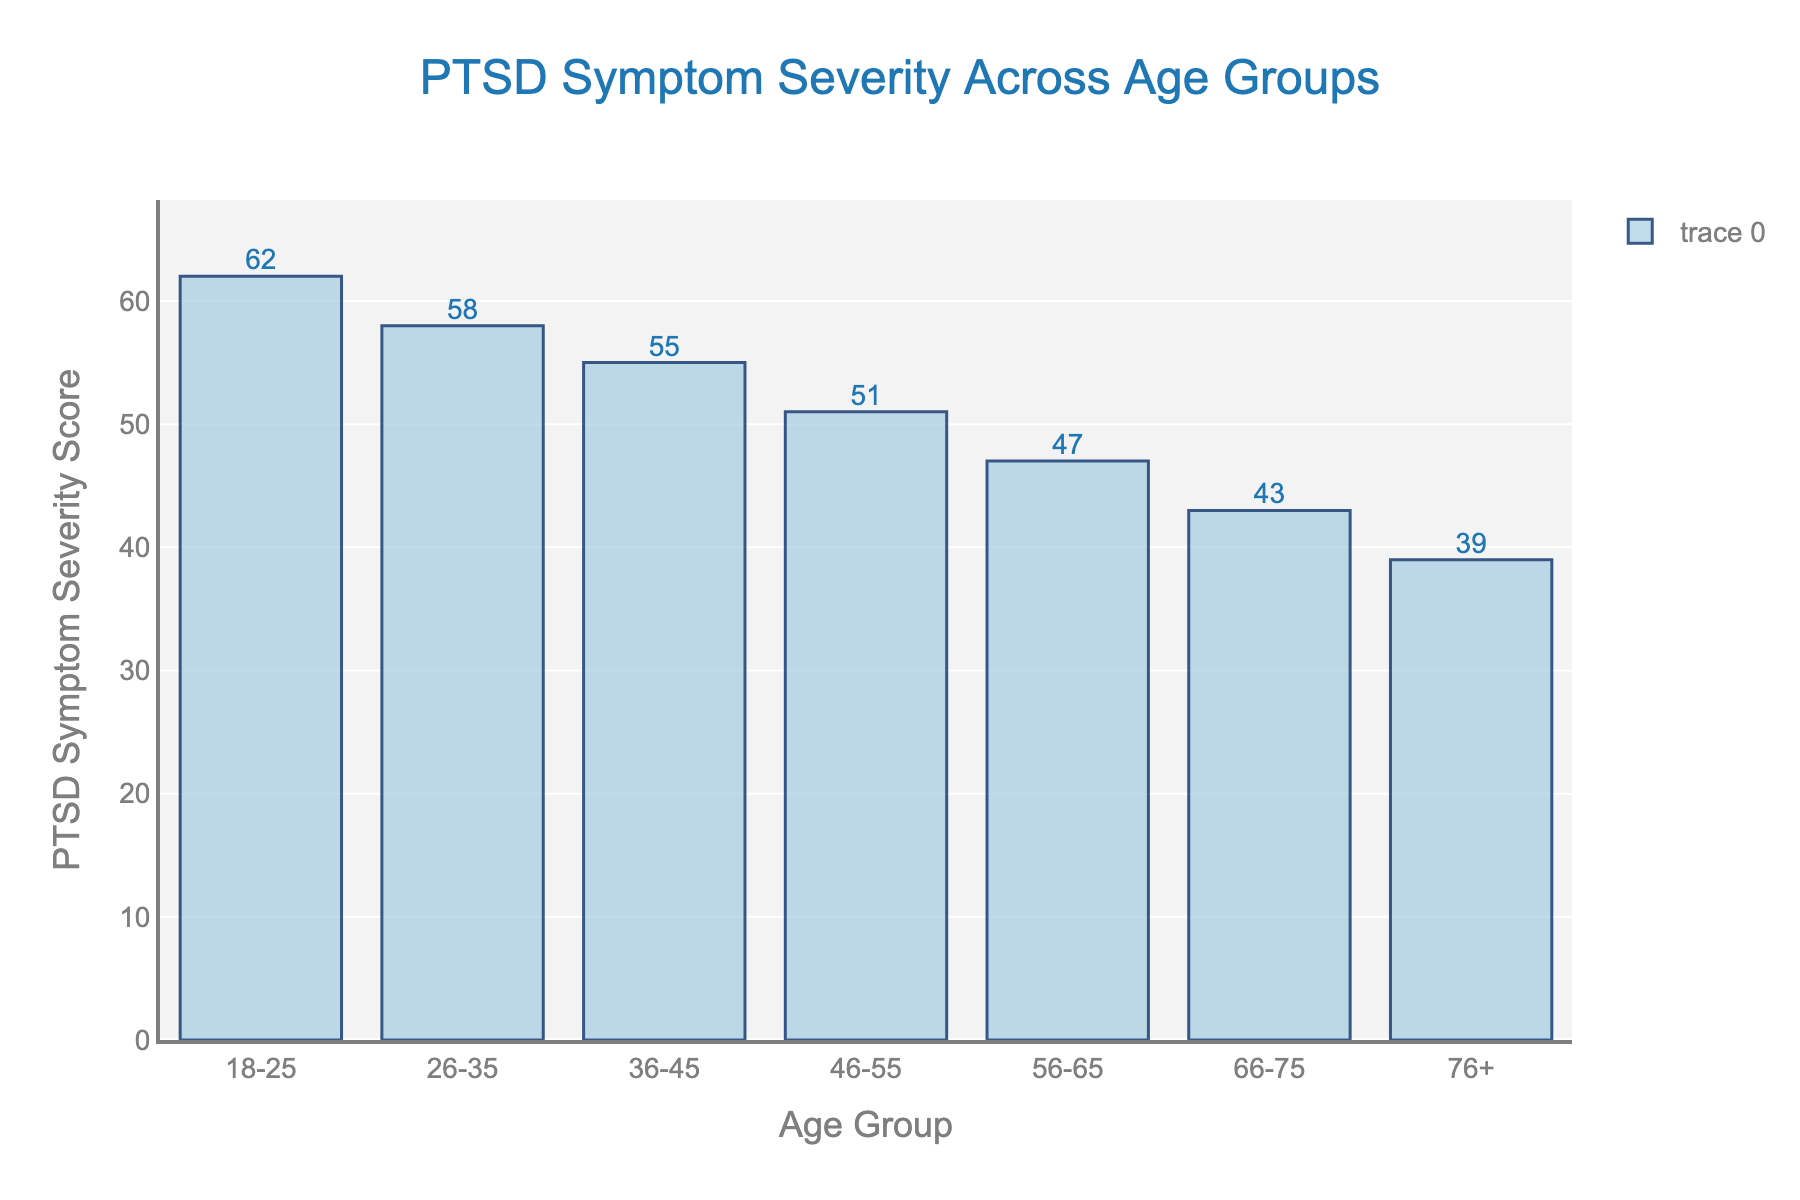What age group has the highest PTSD symptom severity score? The bar for the 18-25 age group is the tallest, indicating it has the highest score.
Answer: 18-25 Which age group has the lowest PTSD symptom severity score? The bar for the 76+ age group is the shortest, indicating it has the lowest score.
Answer: 76+ What is the difference in PTSD symptom severity score between the 26-35 and 56-65 age groups? The score for 26-35 is 58, and for 56-65 it is 47. Subtract 47 from 58 to get the difference.
Answer: 11 What is the average PTSD symptom severity score for the age groups 36-45 and 46-55? Add the scores for 36-45 (55) and 46-55 (51), then divide by 2 to get the average.
Answer: 53 How much lower is the PTSD symptom severity score in the 66-75 age group compared to the 18-25 age group? Subtract the score for 66-75 (43) from the score for 18-25 (62).
Answer: 19 Which two consecutive age groups show the largest drop in PTSD symptom severity scores? The largest drop is between 26-35 (58) and 36-45 (55), which is 3.
Answer: 26-35 to 36-45 What are the PTSD symptom severity scores for the age group 46-55 and how does it visually compare to 56-65? The score for 46-55 is 51 while for 56-65 it is 47. The bar for 46-55 is taller than the bar for 56-65.
Answer: 46-55: 51, 56-65: 47 By how many points does the PTSD symptom severity score decrease in the 76+ age group compared to 56-65? Subtract the score for 76+ (39) from 56-65 (47).
Answer: 8 